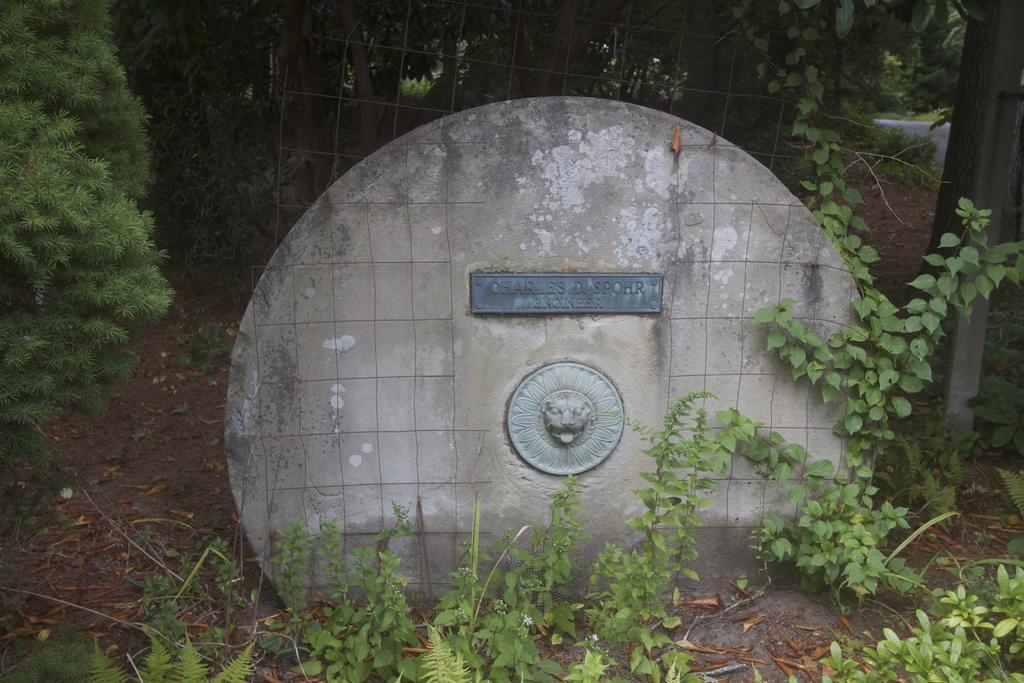What type of vegetation can be seen in the image? There are trees and plants in the image. What is the shape of the wall in the image? The wall in the image is circular. How long does it take to complete the quilt pattern on the wall in the image? There is no quilt pattern present on the wall in the image. What order are the plants arranged in the image? The plants are not arranged in any specific order in the image. 